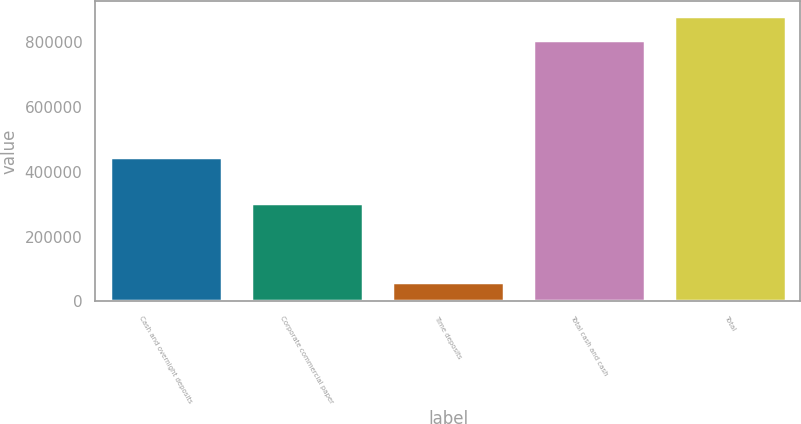Convert chart. <chart><loc_0><loc_0><loc_500><loc_500><bar_chart><fcel>Cash and overnight deposits<fcel>Corporate commercial paper<fcel>Time deposits<fcel>Total cash and cash<fcel>Total<nl><fcel>445582<fcel>302433<fcel>59781<fcel>807796<fcel>882602<nl></chart> 